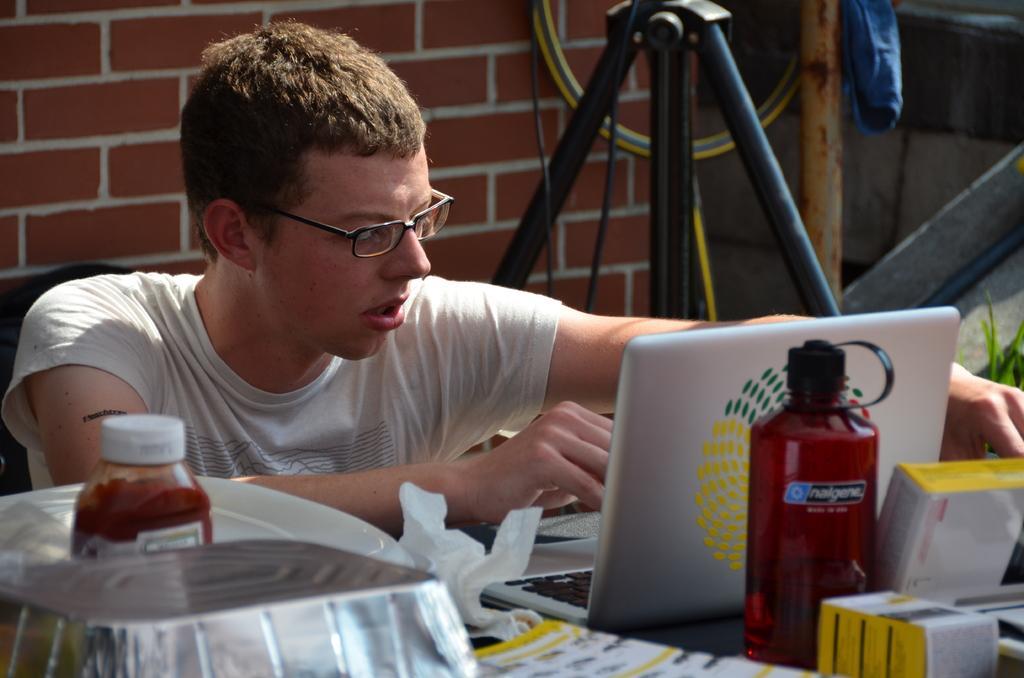In one or two sentences, can you explain what this image depicts? A man is sitting at a table working on his laptop. 